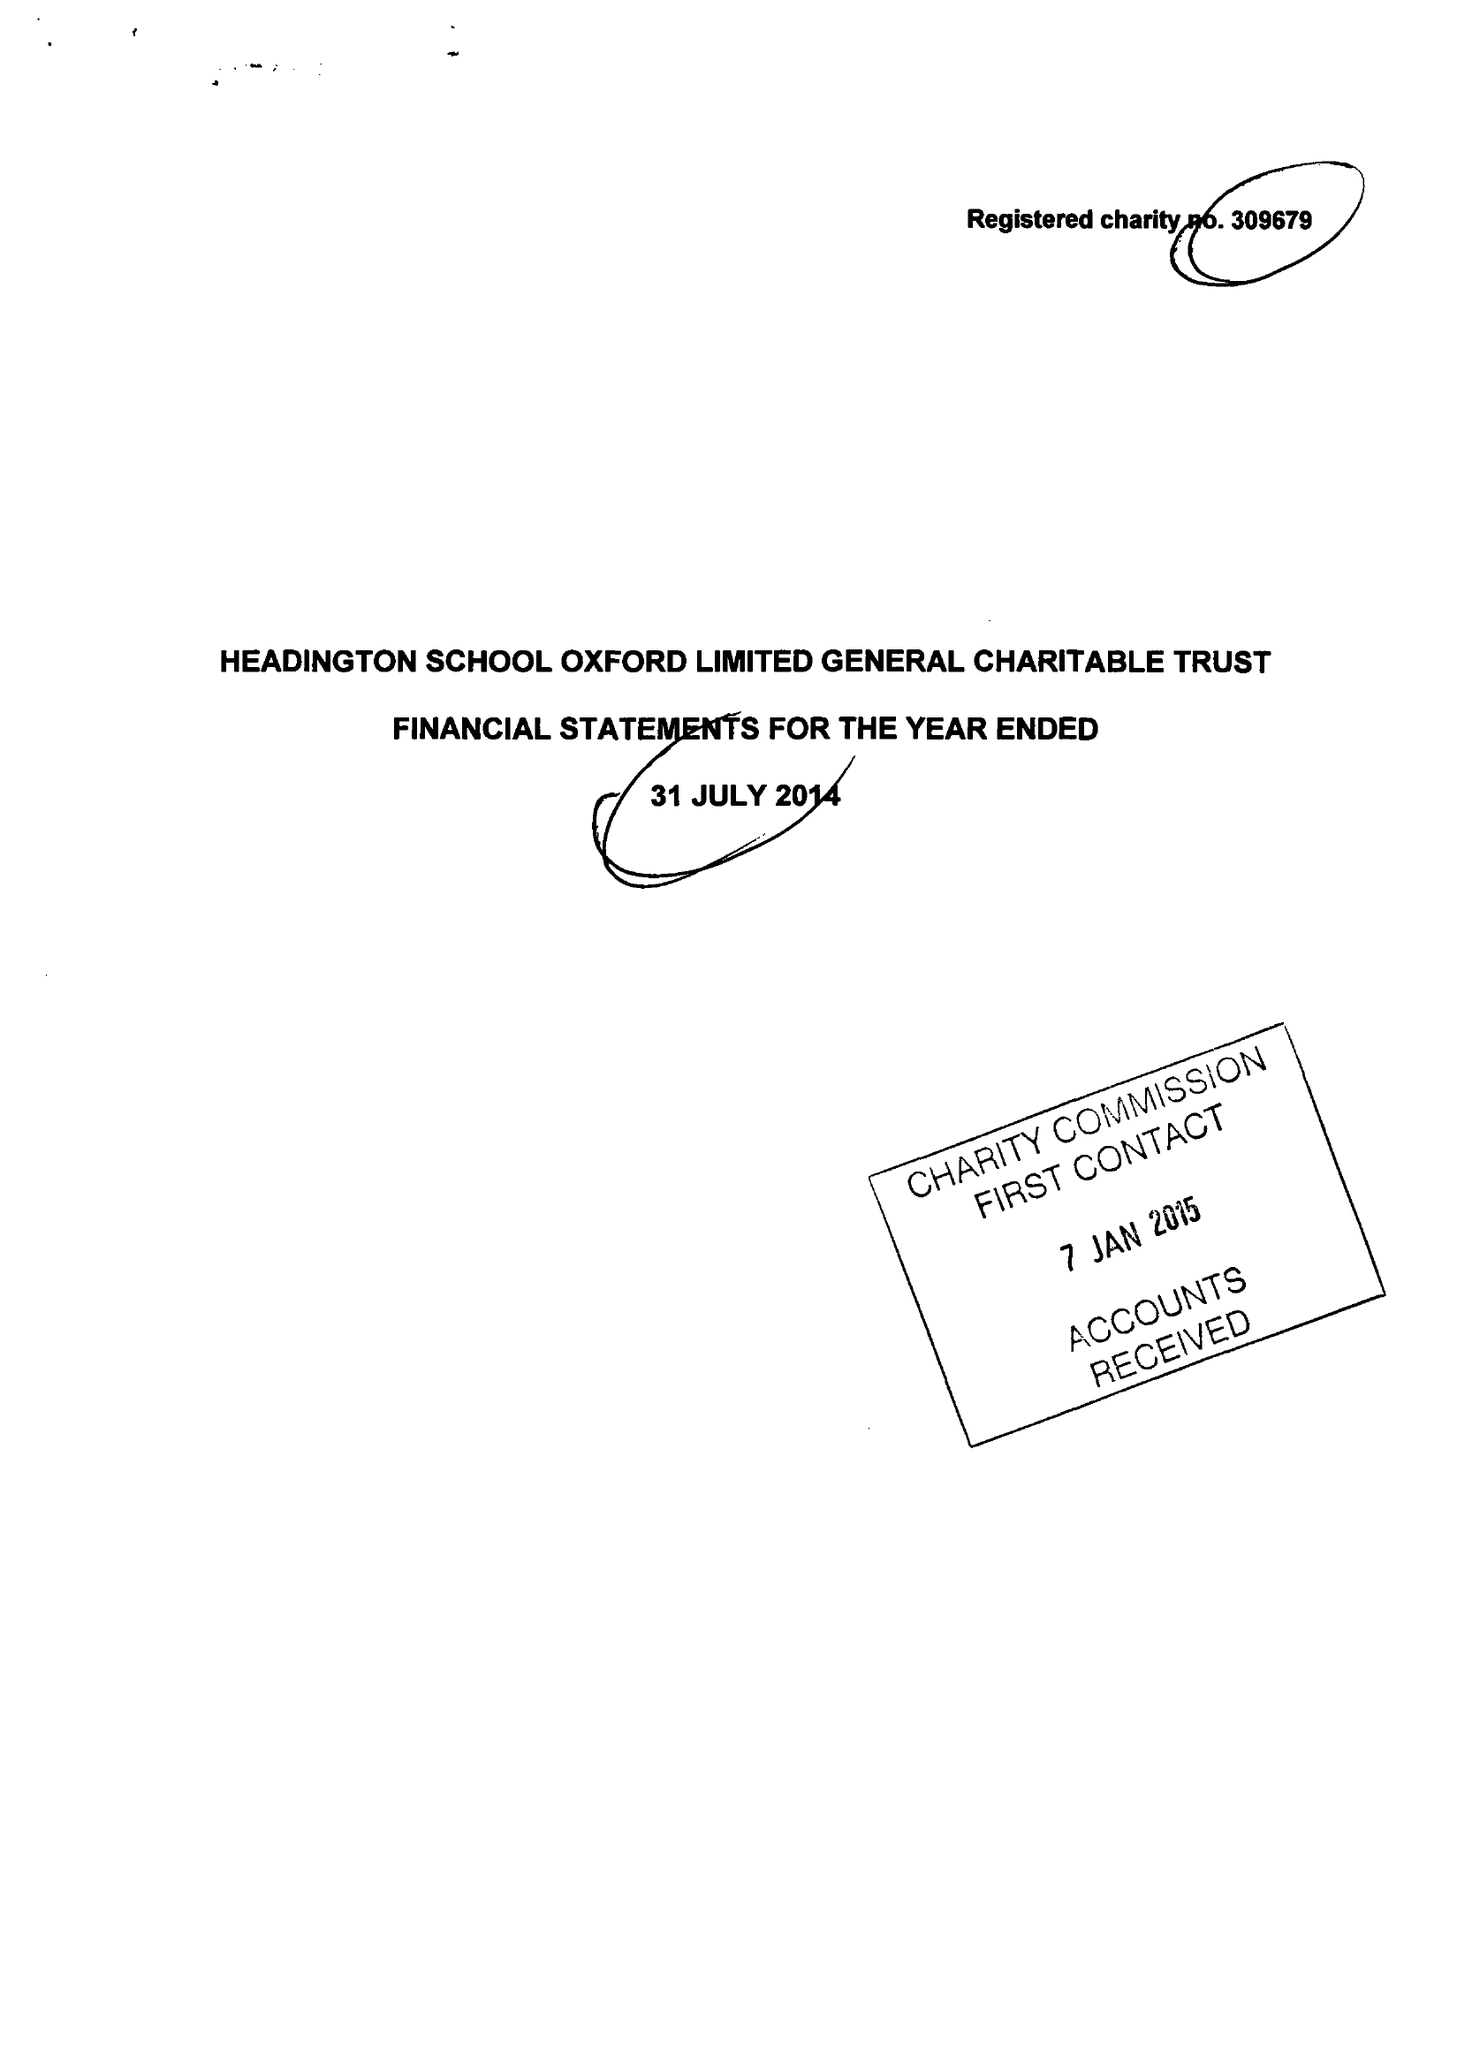What is the value for the address__post_town?
Answer the question using a single word or phrase. OXFORD 